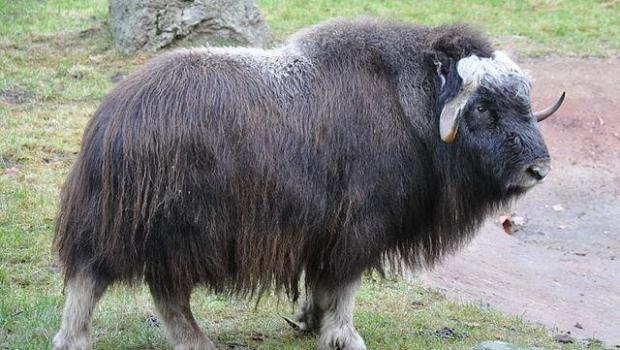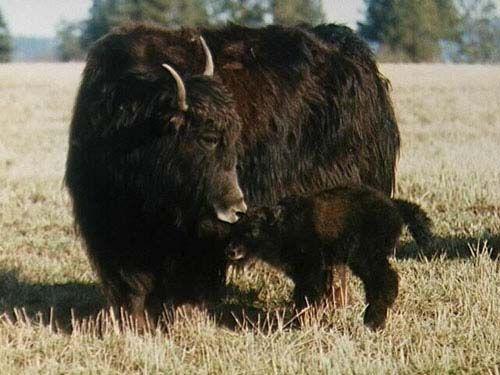The first image is the image on the left, the second image is the image on the right. Evaluate the accuracy of this statement regarding the images: "One man steering a plow is behind two oxen pulling the plow.". Is it true? Answer yes or no. No. The first image is the image on the left, the second image is the image on the right. Evaluate the accuracy of this statement regarding the images: "The left image shows a man walking behind a pair of cattle attached to a farming implement .". Is it true? Answer yes or no. No. 